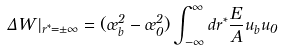<formula> <loc_0><loc_0><loc_500><loc_500>\Delta W | _ { r ^ { * } = \pm \infty } = ( \sigma _ { b } ^ { 2 } - \sigma _ { 0 } ^ { 2 } ) \int _ { - \infty } ^ { \infty } d r ^ { * } \frac { E } { A } u _ { b } u _ { 0 }</formula> 